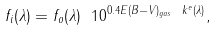Convert formula to latex. <formula><loc_0><loc_0><loc_500><loc_500>f _ { i } ( \lambda ) = f _ { o } ( \lambda ) \ 1 0 ^ { 0 . 4 E ( B - V ) _ { g a s } \ k ^ { e } ( \lambda ) } ,</formula> 